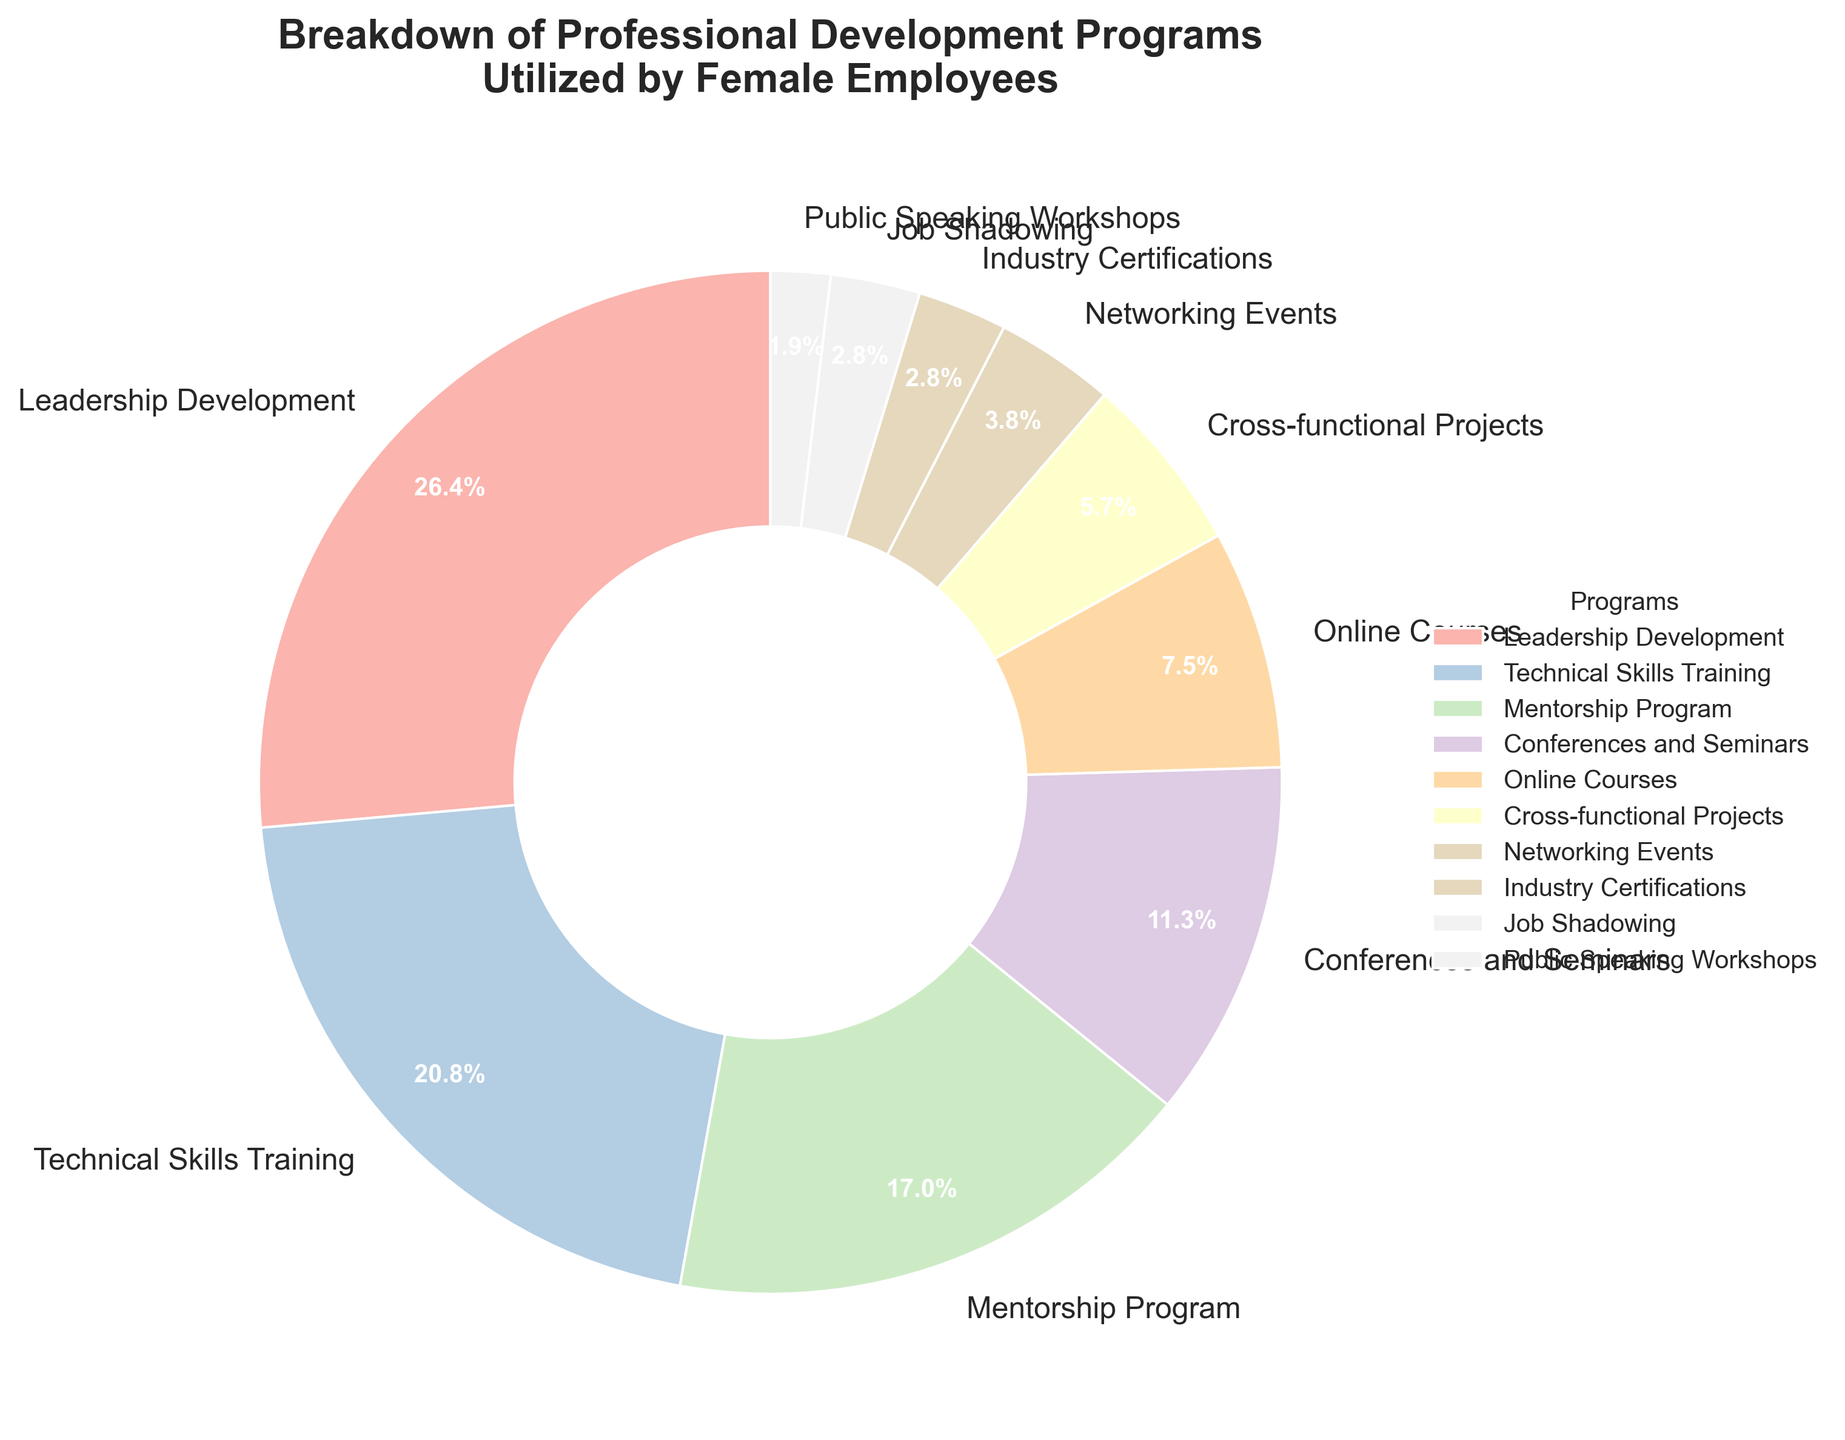What is the percentage of female employees utilizing the Leadership Development program? The slice labeled "Leadership Development" shows its percentage directly on the pie chart.
Answer: 28% Which program has a higher percentage of female employees utilizing it: Technical Skills Training or Mentorship Program? Compare the percentages directly from the pie chart: Technical Skills Training (22%) vs. Mentorship Program (18%).
Answer: Technical Skills Training What is the combined percentage of female employees participating in Online Courses, Cross-functional Projects, and Networking Events? Sum the percentages of Online Courses (8%), Cross-functional Projects (6%), and Networking Events (4%) from the pie chart: 8% + 6% + 4%.
Answer: 18% Which development program has the lowest percentage of utilization among female employees? Identify the slice with the smallest percentage, which is labeled as "Public Speaking Workshops."
Answer: Public Speaking Workshops How much higher is the percentage of female employees utilizing Leadership Development compared to those participating in Job Shadowing? Subtract the percentage of Job Shadowing (3%) from Leadership Development (28%) using the pie chart: 28% - 3%.
Answer: 25% What is the percentage difference between Conferences and Seminars and Industry Certifications? Subtract the percentage of Industry Certifications (3%) from Conferences and Seminars (12%) using the pie chart: 12% - 3%.
Answer: 9% Rank the top three professional development programs by percentage of utilization. Sort the program names by their respective percentages: Leadership Development (28%), Technical Skills Training (22%), and Mentorship Program (18%).
Answer: Leadership Development, Technical Skills Training, Mentorship Program How does the percentage of female employees participating in Conferences and Seminars compare to Online Courses and Job Shadowing combined? Compare Conferences and Seminars (12%) to the sum of Online Courses (8%) and Job Shadowing (3%): 12% vs. 8% + 3% (11%).
Answer: Higher If we group Leadership Development and Technical Skills Training together, what percentage of female employees are using these combined programs? Sum the percentages of Leadership Development (28%) and Technical Skills Training (22%) from the pie chart: 28% + 22%.
Answer: 50% What is the percentage breakdown of female employees utilizing networking-related programs (Networking Events and Job Shadowing)? Sum the percentages of Networking Events (4%) and Job Shadowing (3%) directly from the pie chart: 4% + 3%.
Answer: 7% 